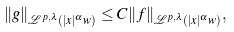<formula> <loc_0><loc_0><loc_500><loc_500>\| g \| _ { \mathcal { L } ^ { p , \lambda } ( | x | ^ { \alpha } w ) } \leq C \| f \| _ { \mathcal { L } ^ { p , \lambda } ( | x | ^ { \alpha } w ) } ,</formula> 